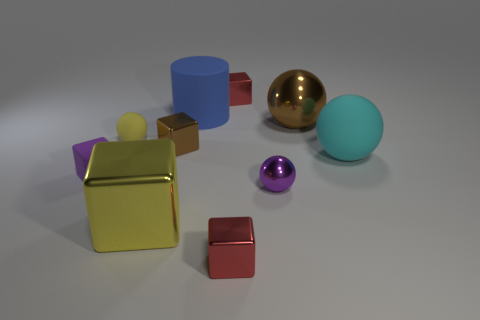There is a tiny ball that is on the left side of the blue object; does it have the same color as the large rubber thing to the left of the purple metal sphere?
Your answer should be very brief. No. There is a yellow object that is the same shape as the big cyan rubber object; what size is it?
Ensure brevity in your answer.  Small. Do the tiny block that is left of the small brown shiny block and the tiny red object that is behind the small purple rubber object have the same material?
Ensure brevity in your answer.  No. How many matte things are either tiny yellow balls or brown spheres?
Give a very brief answer. 1. What is the material of the tiny cube that is behind the brown thing that is to the right of the red metal thing behind the big brown shiny ball?
Ensure brevity in your answer.  Metal. Is the shape of the tiny red metallic object that is in front of the big blue cylinder the same as the big rubber thing that is behind the cyan ball?
Provide a short and direct response. No. There is a tiny metal thing left of the red cube in front of the blue thing; what color is it?
Ensure brevity in your answer.  Brown. What number of cylinders are tiny yellow rubber objects or red shiny objects?
Offer a very short reply. 0. There is a small red cube behind the big blue rubber thing on the left side of the big metallic ball; how many yellow matte things are to the right of it?
Keep it short and to the point. 0. What is the size of the thing that is the same color as the tiny rubber cube?
Make the answer very short. Small. 